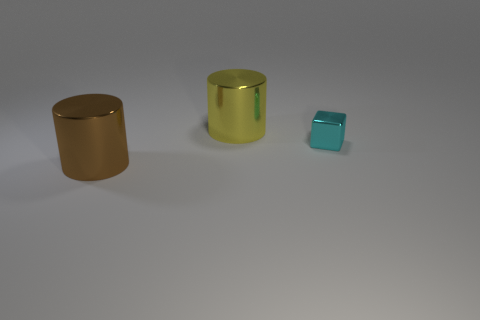How many things are either small objects or big shiny cylinders?
Offer a very short reply. 3. Is there any other thing that has the same material as the yellow cylinder?
Provide a succinct answer. Yes. What is the shape of the big brown object?
Provide a short and direct response. Cylinder. There is a cyan thing that is on the right side of the shiny cylinder that is left of the yellow metallic cylinder; what shape is it?
Your response must be concise. Cube. What number of yellow objects are either big metal cylinders or tiny cubes?
Keep it short and to the point. 1. Are there any big things that have the same material as the large yellow cylinder?
Your response must be concise. Yes. What is the shape of the object that is both behind the big brown cylinder and to the left of the cyan metallic block?
Your answer should be very brief. Cylinder. How many large objects are metallic cubes or purple blocks?
Make the answer very short. 0. What material is the yellow cylinder?
Ensure brevity in your answer.  Metal. How many other objects are the same shape as the big yellow object?
Provide a succinct answer. 1. 